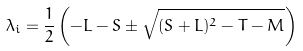Convert formula to latex. <formula><loc_0><loc_0><loc_500><loc_500>\lambda _ { i } = \frac { 1 } { 2 } \left ( - L - S \pm \sqrt { ( S + L ) ^ { 2 } - T - M } \right )</formula> 